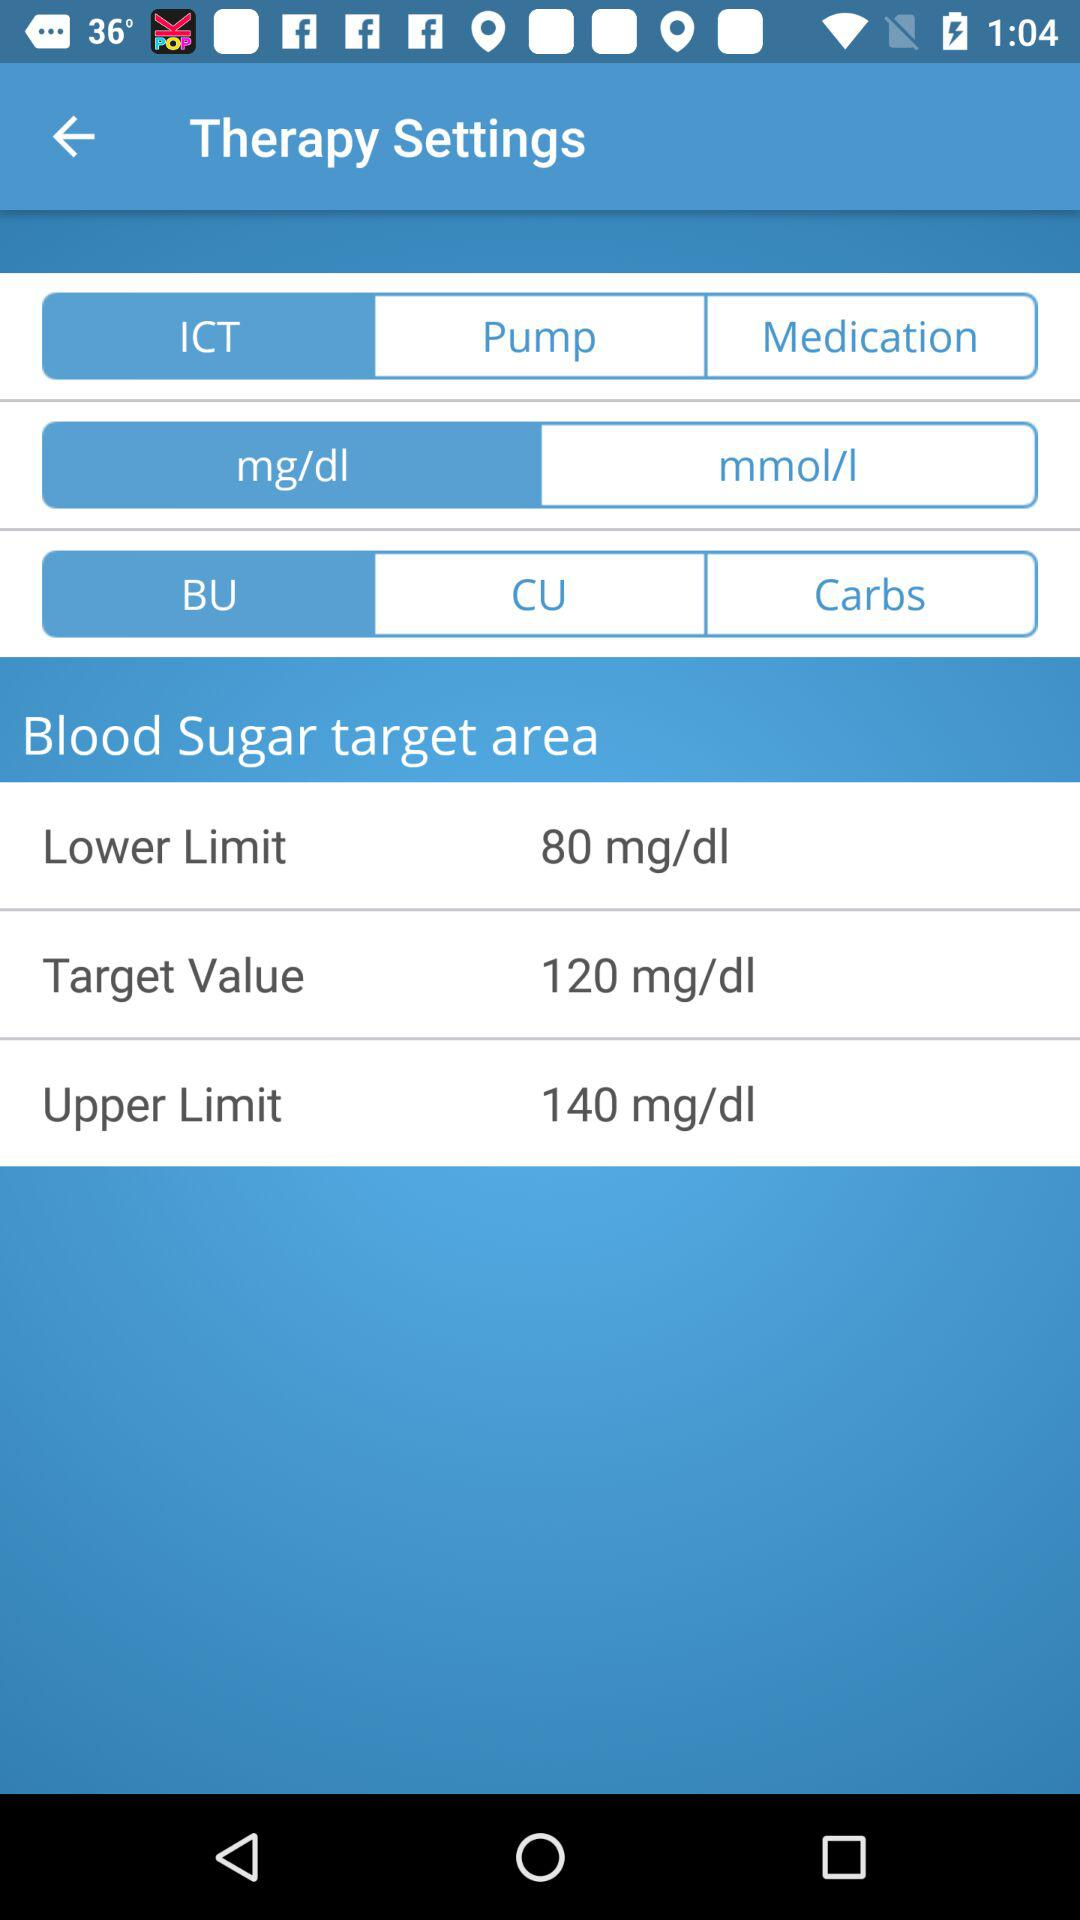Which option is selected out of "mg/dl" and "mmol/l"? The selected option is "mg/dl". 